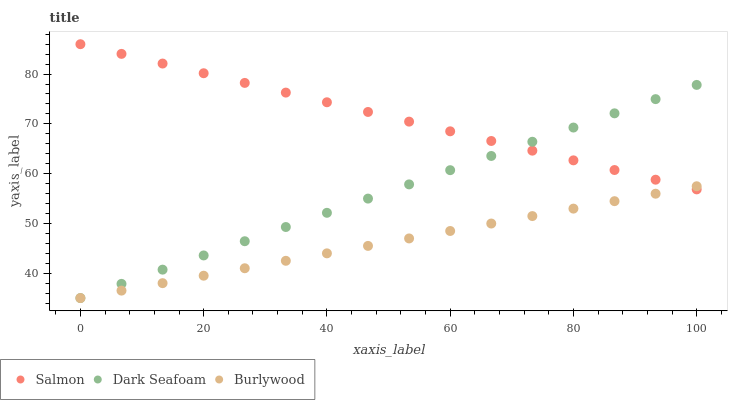Does Burlywood have the minimum area under the curve?
Answer yes or no. Yes. Does Salmon have the maximum area under the curve?
Answer yes or no. Yes. Does Dark Seafoam have the minimum area under the curve?
Answer yes or no. No. Does Dark Seafoam have the maximum area under the curve?
Answer yes or no. No. Is Burlywood the smoothest?
Answer yes or no. Yes. Is Dark Seafoam the roughest?
Answer yes or no. Yes. Is Salmon the smoothest?
Answer yes or no. No. Is Salmon the roughest?
Answer yes or no. No. Does Burlywood have the lowest value?
Answer yes or no. Yes. Does Salmon have the lowest value?
Answer yes or no. No. Does Salmon have the highest value?
Answer yes or no. Yes. Does Dark Seafoam have the highest value?
Answer yes or no. No. Does Burlywood intersect Dark Seafoam?
Answer yes or no. Yes. Is Burlywood less than Dark Seafoam?
Answer yes or no. No. Is Burlywood greater than Dark Seafoam?
Answer yes or no. No. 